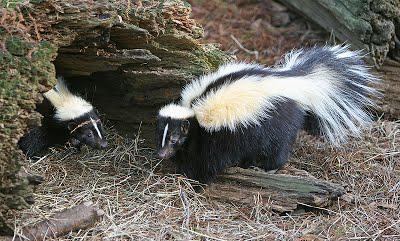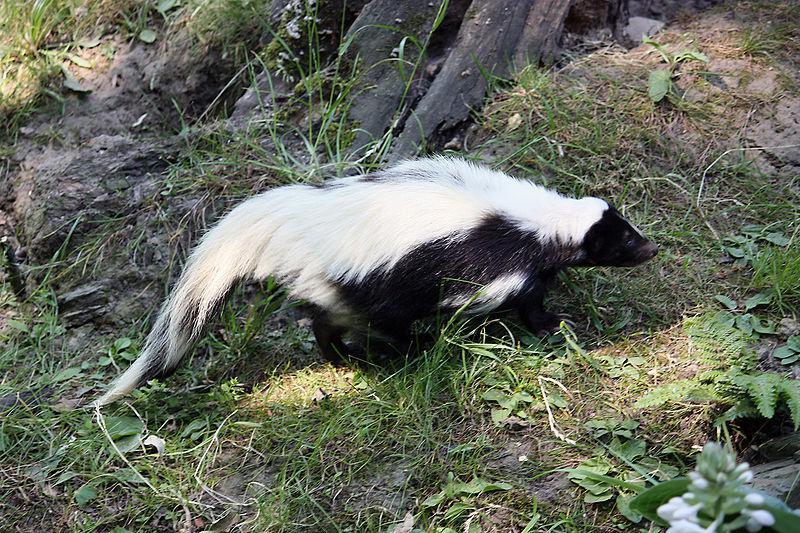The first image is the image on the left, the second image is the image on the right. Evaluate the accuracy of this statement regarding the images: "There are two skunks that are positioned in a similar direction.". Is it true? Answer yes or no. No. The first image is the image on the left, the second image is the image on the right. Assess this claim about the two images: "Each image contains exactly one skunk, which is on all fours with its body turned rightward.". Correct or not? Answer yes or no. No. 